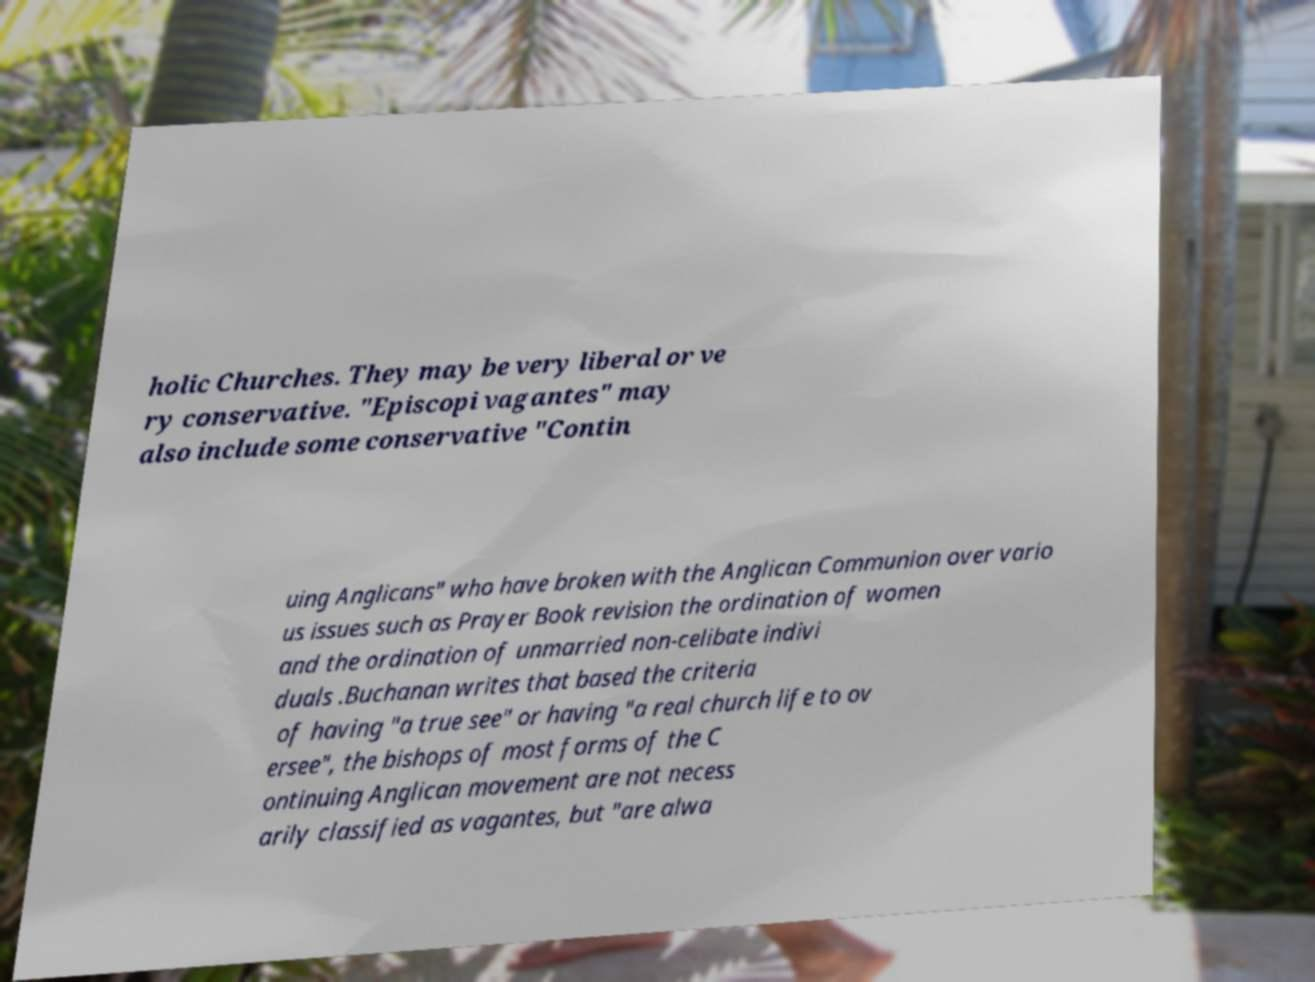Could you assist in decoding the text presented in this image and type it out clearly? holic Churches. They may be very liberal or ve ry conservative. "Episcopi vagantes" may also include some conservative "Contin uing Anglicans" who have broken with the Anglican Communion over vario us issues such as Prayer Book revision the ordination of women and the ordination of unmarried non-celibate indivi duals .Buchanan writes that based the criteria of having "a true see" or having "a real church life to ov ersee", the bishops of most forms of the C ontinuing Anglican movement are not necess arily classified as vagantes, but "are alwa 